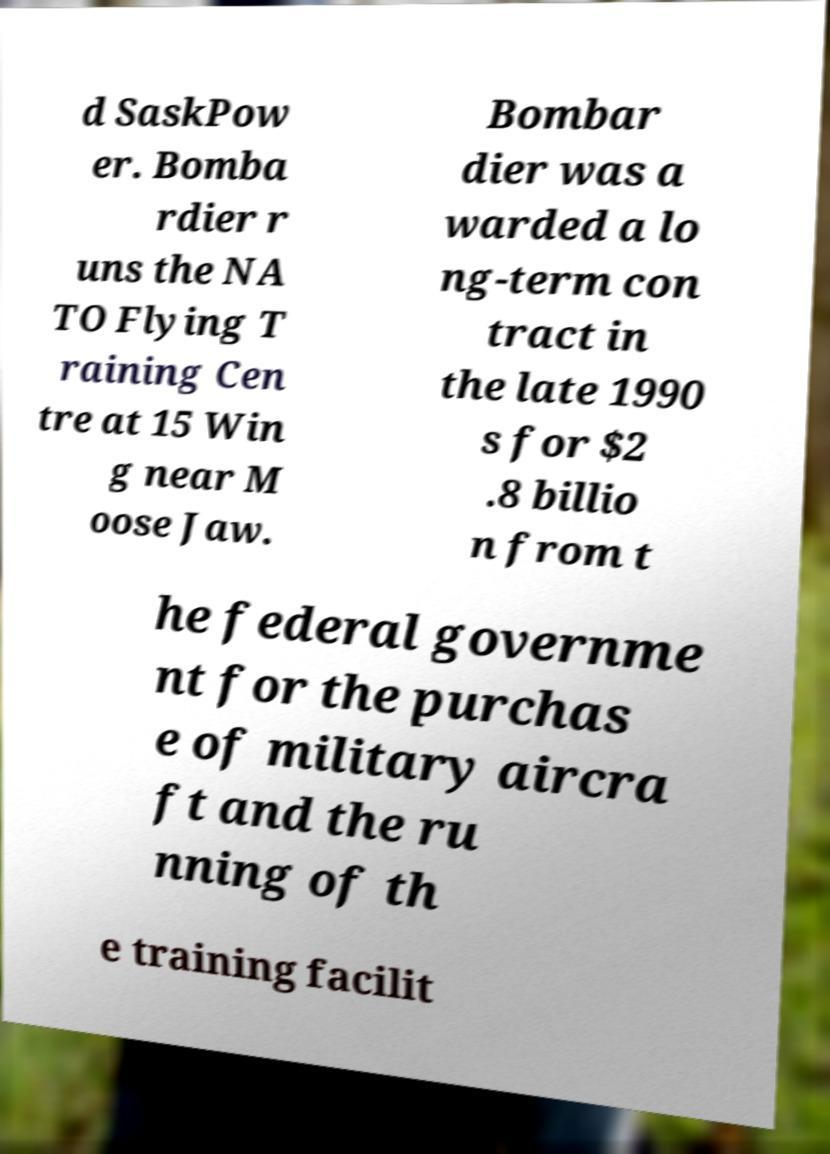Please identify and transcribe the text found in this image. d SaskPow er. Bomba rdier r uns the NA TO Flying T raining Cen tre at 15 Win g near M oose Jaw. Bombar dier was a warded a lo ng-term con tract in the late 1990 s for $2 .8 billio n from t he federal governme nt for the purchas e of military aircra ft and the ru nning of th e training facilit 